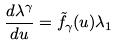Convert formula to latex. <formula><loc_0><loc_0><loc_500><loc_500>\frac { d \lambda ^ { \gamma } } { d u } = { \tilde { f } } _ { \gamma } ( u ) \lambda _ { 1 }</formula> 